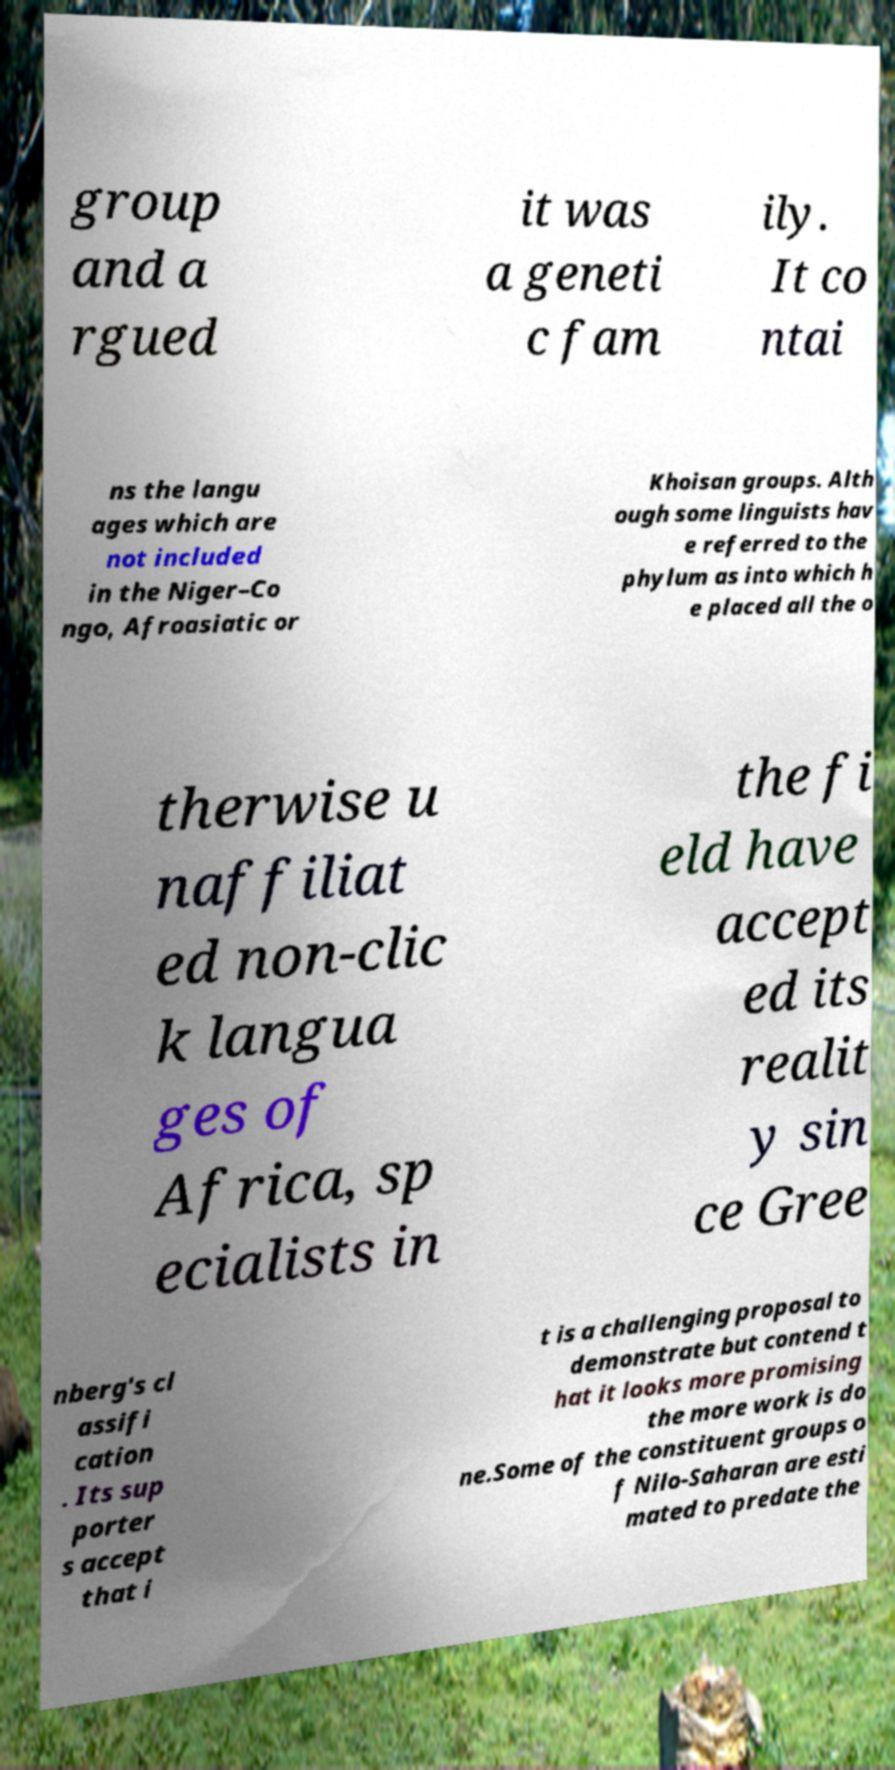For documentation purposes, I need the text within this image transcribed. Could you provide that? group and a rgued it was a geneti c fam ily. It co ntai ns the langu ages which are not included in the Niger–Co ngo, Afroasiatic or Khoisan groups. Alth ough some linguists hav e referred to the phylum as into which h e placed all the o therwise u naffiliat ed non-clic k langua ges of Africa, sp ecialists in the fi eld have accept ed its realit y sin ce Gree nberg's cl assifi cation . Its sup porter s accept that i t is a challenging proposal to demonstrate but contend t hat it looks more promising the more work is do ne.Some of the constituent groups o f Nilo-Saharan are esti mated to predate the 